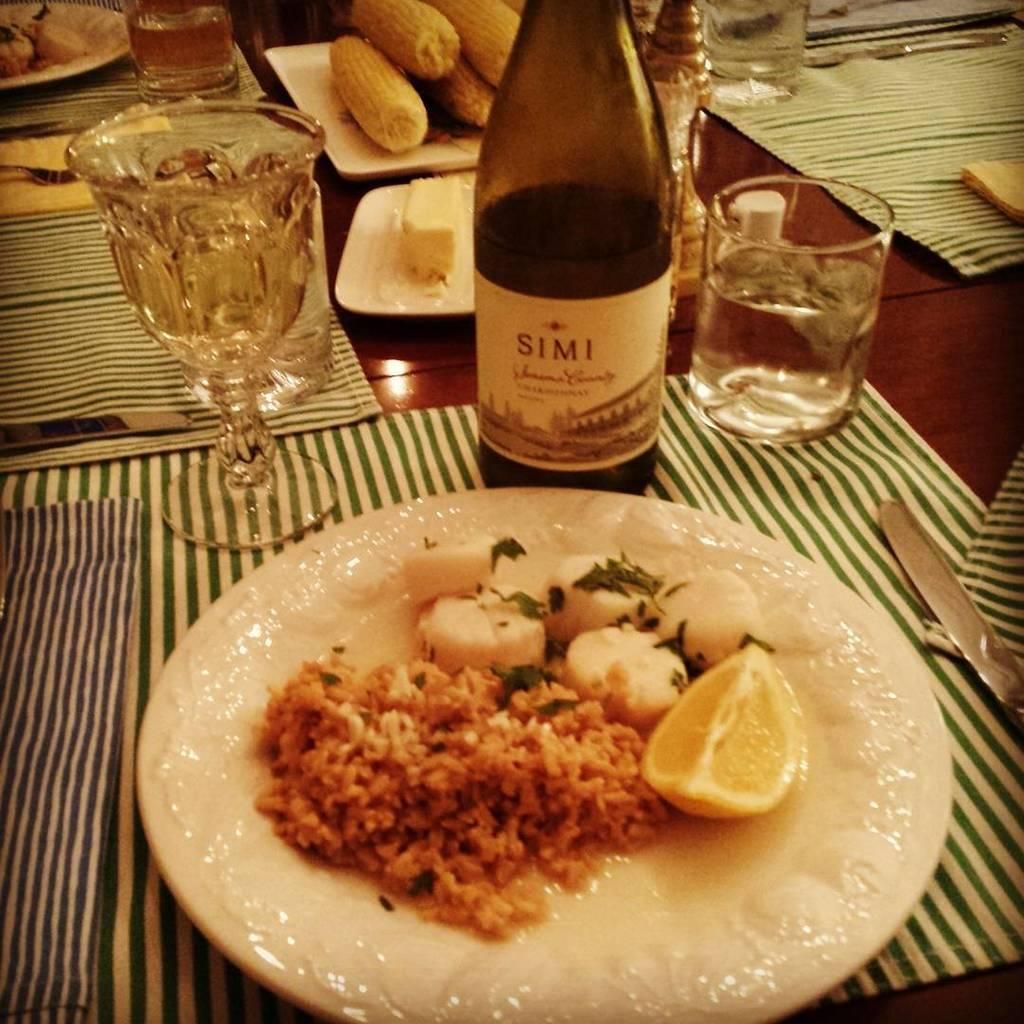<image>
Describe the image concisely. A formal dinner plate of food of scallops and rice with a bottle of wine From Simi winery. 